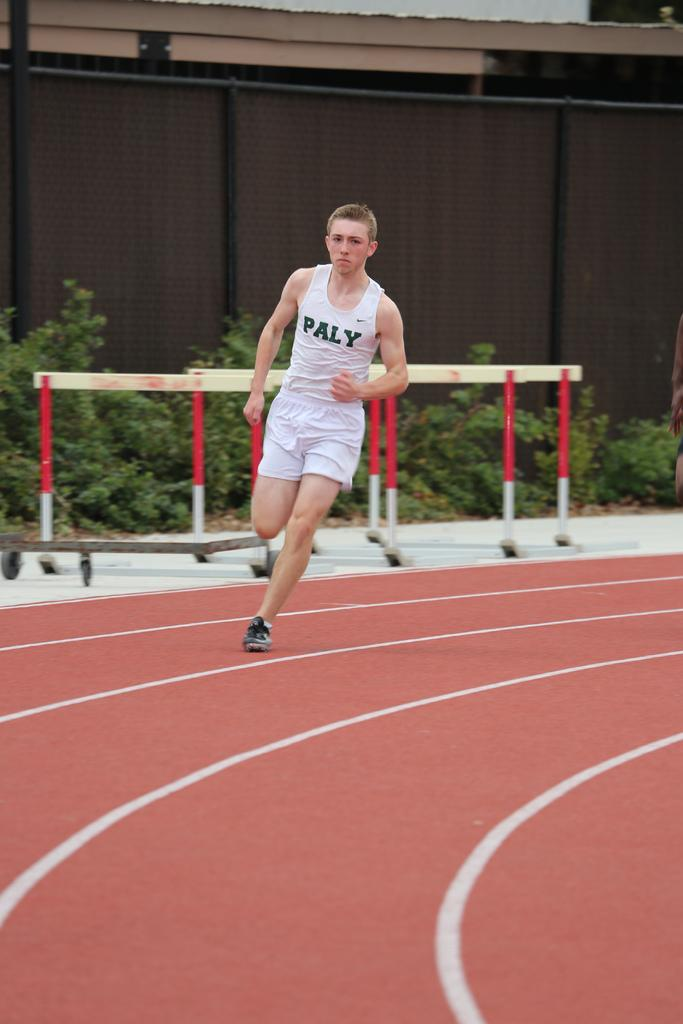What is the main action being performed by the person in the image? The person is running in the foreground of the image. What surface is the person running on? The person is running on the ground. What can be seen in the background of the image? There is a fence, plants, and a wall in the background of the image. Can you describe the time of day when the image was likely taken? The image was likely taken during the day, as there is sufficient light to see the details clearly. How many attempts did the person make before successfully performing a skate trick in the image? There is no skateboard or skate trick present in the image; the person is simply running. What type of fire can be seen in the background of the image? There is no fire present in the image; the background features a fence, plants, and a wall. 